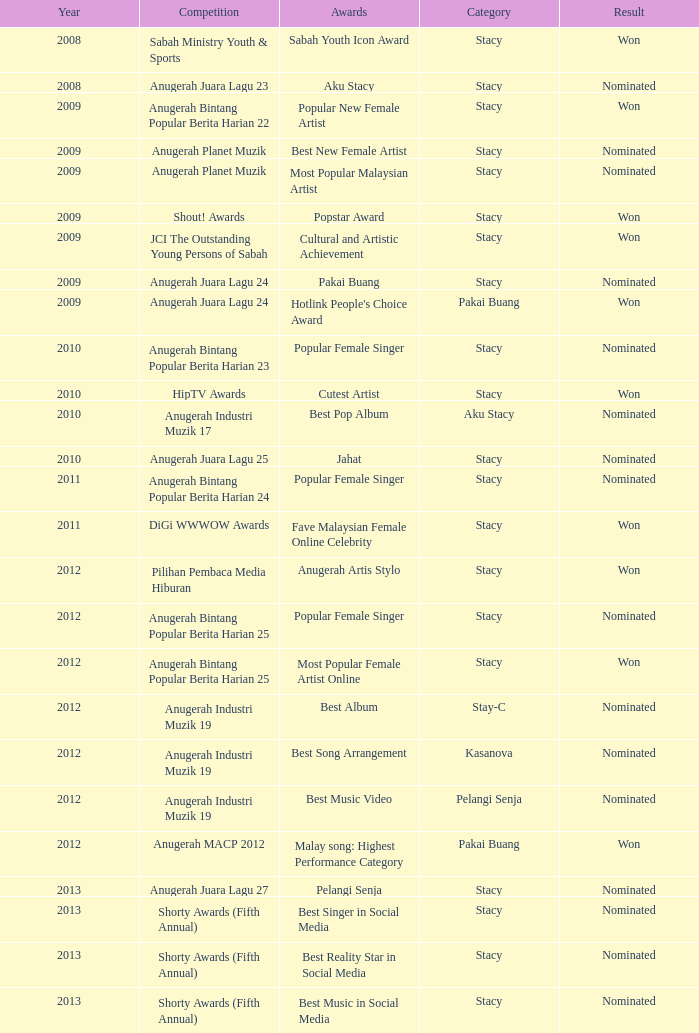What year has Stacy as the category and award of Best Reality Star in Social Media? 2013.0. 